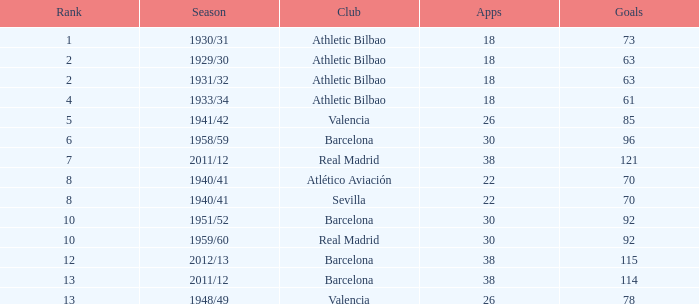Parse the full table. {'header': ['Rank', 'Season', 'Club', 'Apps', 'Goals'], 'rows': [['1', '1930/31', 'Athletic Bilbao', '18', '73'], ['2', '1929/30', 'Athletic Bilbao', '18', '63'], ['2', '1931/32', 'Athletic Bilbao', '18', '63'], ['4', '1933/34', 'Athletic Bilbao', '18', '61'], ['5', '1941/42', 'Valencia', '26', '85'], ['6', '1958/59', 'Barcelona', '30', '96'], ['7', '2011/12', 'Real Madrid', '38', '121'], ['8', '1940/41', 'Atlético Aviación', '22', '70'], ['8', '1940/41', 'Sevilla', '22', '70'], ['10', '1951/52', 'Barcelona', '30', '92'], ['10', '1959/60', 'Real Madrid', '30', '92'], ['12', '2012/13', 'Barcelona', '38', '115'], ['13', '2011/12', 'Barcelona', '38', '114'], ['13', '1948/49', 'Valencia', '26', '78']]} What season was Barcelona ranked higher than 12, had more than 96 goals and had more than 26 apps? 2011/12. 